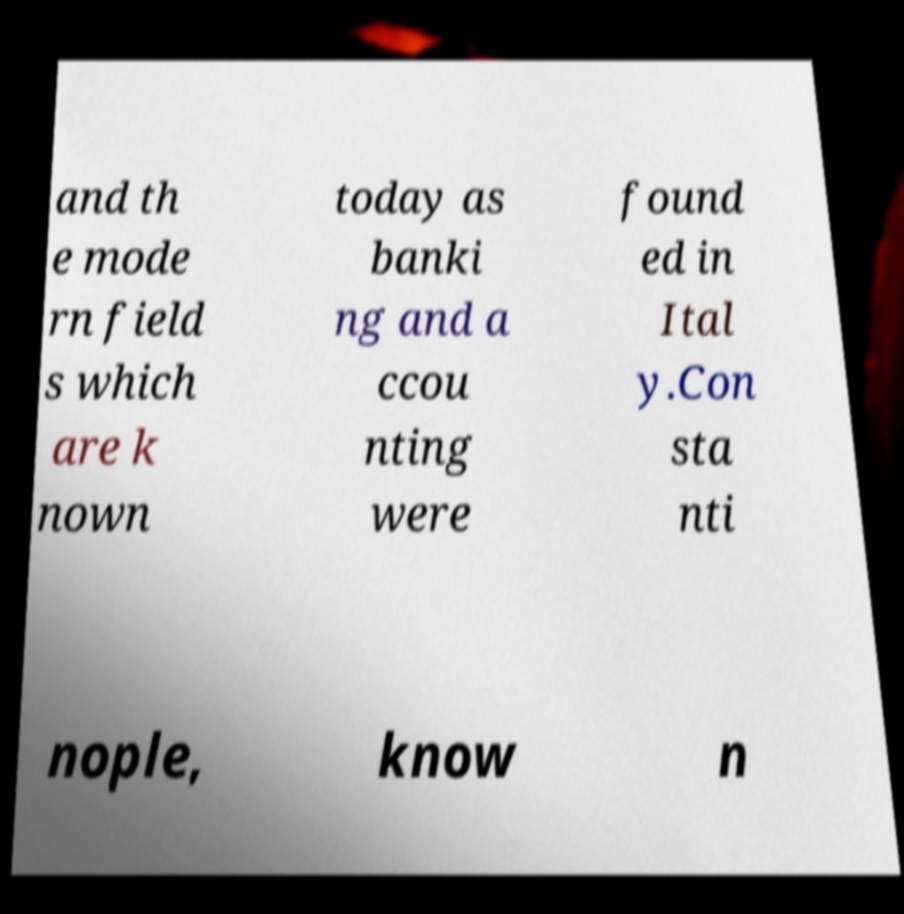There's text embedded in this image that I need extracted. Can you transcribe it verbatim? and th e mode rn field s which are k nown today as banki ng and a ccou nting were found ed in Ital y.Con sta nti nople, know n 